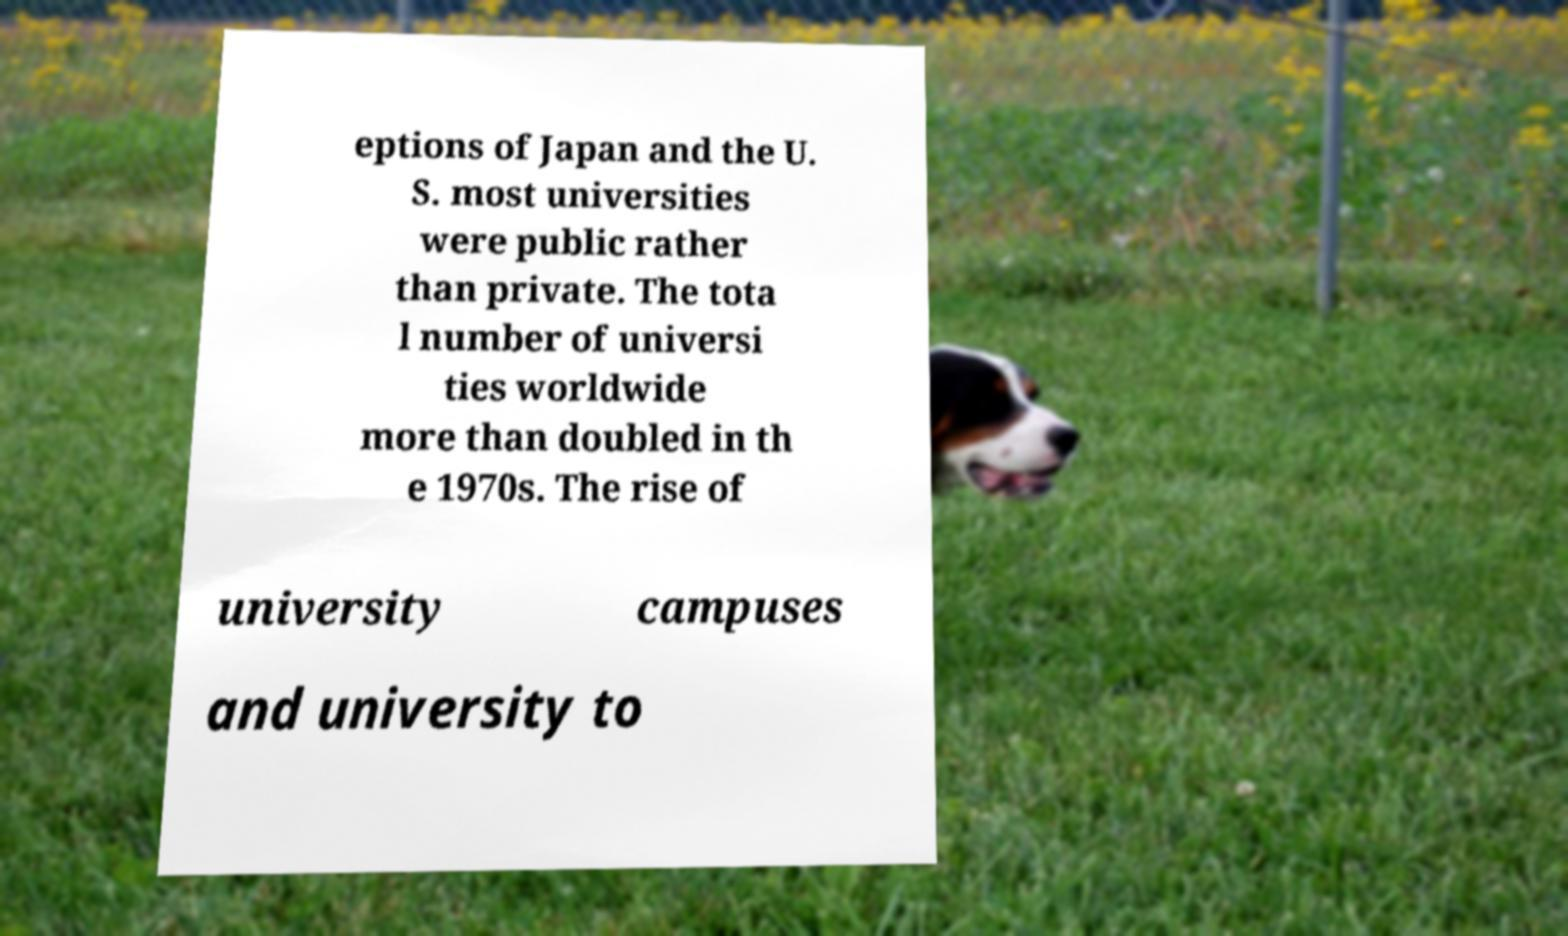Could you assist in decoding the text presented in this image and type it out clearly? eptions of Japan and the U. S. most universities were public rather than private. The tota l number of universi ties worldwide more than doubled in th e 1970s. The rise of university campuses and university to 